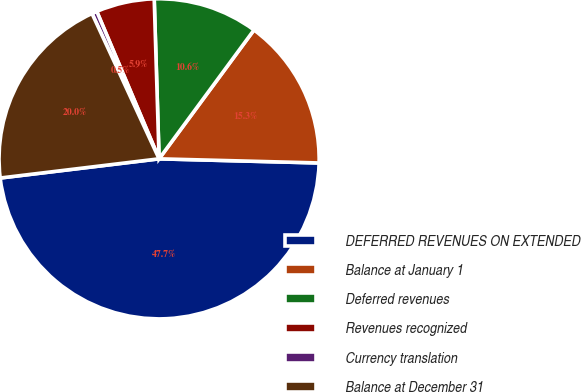Convert chart. <chart><loc_0><loc_0><loc_500><loc_500><pie_chart><fcel>DEFERRED REVENUES ON EXTENDED<fcel>Balance at January 1<fcel>Deferred revenues<fcel>Revenues recognized<fcel>Currency translation<fcel>Balance at December 31<nl><fcel>47.68%<fcel>15.31%<fcel>10.59%<fcel>5.88%<fcel>0.52%<fcel>20.03%<nl></chart> 